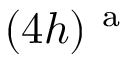Convert formula to latex. <formula><loc_0><loc_0><loc_500><loc_500>( 4 h ) ^ { a }</formula> 